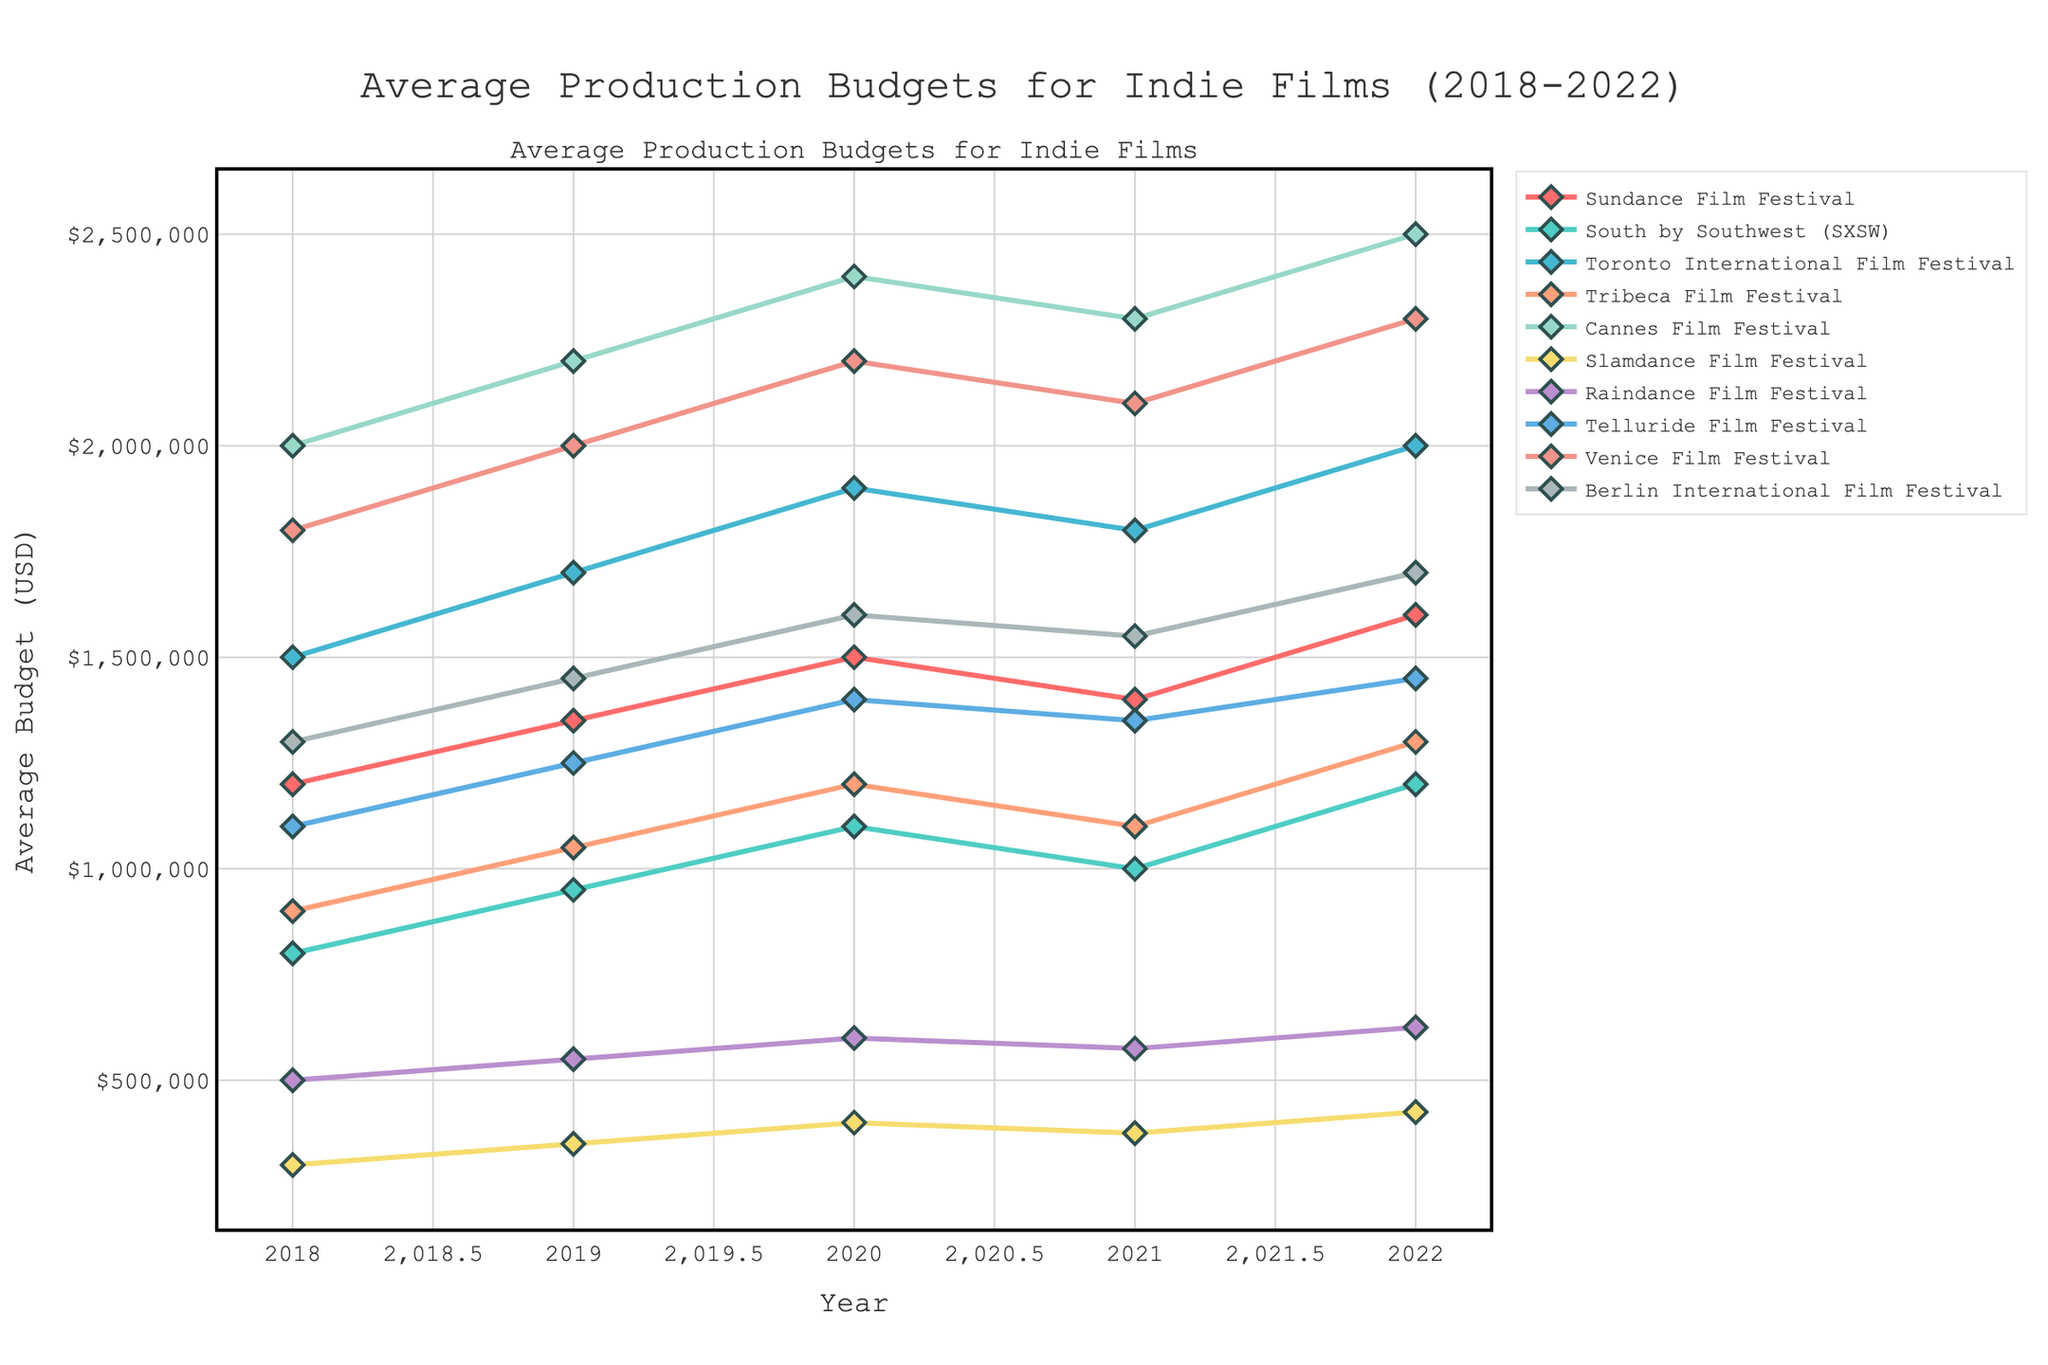what was the approximate budget difference for films premiered at the Sundance Film Festival between 2018 and 2022? To find the budget difference, subtract the budget in 2018 ($1,200,000) from the budget in 2022 ($1,600,000). The difference is $1,600,000 - $1,200,000 = $400,000.
Answer: $400,000 Which film festival had the highest average production budget in 2022? Look for the highest y-value data point associated with 2022 across all festivals. Cannes Film Festival in 2022 has the highest value, which is $2,500,000.
Answer: Cannes Film Festival Between which years did the Toronto International Film Festival see the greatest increase in average budget? Calculate the year-on-year differences for the Toronto International Film Festival: 2018 to 2019 ($1,700,000 - $1,500,000 = $200,000), 2019 to 2020 ($1,900,000 - $1,700,000 = $200,000), 2020 to 2021 ($1,800,000 - $1,900,000 = -$100,000), 2021 to 2022 ($2,000,000 - $1,800,000 = $200,000). The greatest increase is $200,000, which occurred between 2018-2019, 2019-2020, and 2021-2022.
Answer: 2018-2019, 2019-2020, 2021-2022 (tie) Which festivals had lower budgets in 2021 than in 2020? Compare the 2020 vs. 2021 budgets for each festival. The affected festivals are Toronto International Film Festival ($1,900,000 to $1,800,000), Tribeca Film Festival ($1,200,000 to $1,100,000), and Venice Film Festival ($2,200,000 to $2,100,000).
Answer: Toronto International Film Festival, Tribeca Film Festival, Venice Film Festival What’s the average budget for Telluride Film Festival over the 5 years shown? Add the budgets for each year ($1,100,000 + $1,250,000 + $1,400,000 + $1,350,000 + $1,450,000) and divide by 5. Total is $6,550,000. The average is $6,550,000 / 5 = $1,310,000.
Answer: $1,310,000 Which festival showed the most consistent (least variability) budget trend from 2018 to 2022? This can be determined by observing which line appears the most stable with minimal fluctuations. Telluride Film Festival has a consistent trend with small changes each year ($1,100,000 to $1,250,000 to $1,400,000 to $1,350,000 to $1,450,000).
Answer: Telluride Film Festival How does the ending budget in 2022 for Raindance compare to the starting budget in 2018 for SXSW? Locate the budget for Raindance in 2022 ($625,000) and SXSW in 2018 ($800,000), then compare these values. Raindance ($625,000) is smaller than SXSW's starting budget ($800,000).
Answer: Smaller By how much did the average budget of films at the Cannes Film Festival increase between 2018 to 2022? Subtract the budget of Cannes in 2018 ($2,000,000) from the budget in 2022 ($2,500,000). The increase is $2,500,000 - $2,000,000 = $500,000.
Answer: $500,000 